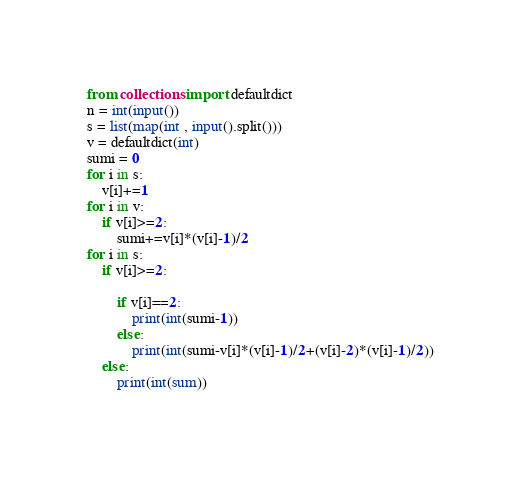Convert code to text. <code><loc_0><loc_0><loc_500><loc_500><_Python_>from collections import defaultdict
n = int(input())
s = list(map(int , input().split()))
v = defaultdict(int)
sumi = 0
for i in s:
    v[i]+=1
for i in v:
    if v[i]>=2:
        sumi+=v[i]*(v[i]-1)/2
for i in s:
    if v[i]>=2:

        if v[i]==2:
            print(int(sumi-1))
        else:
            print(int(sumi-v[i]*(v[i]-1)/2+(v[i]-2)*(v[i]-1)/2))
    else:
        print(int(sum))
    
</code> 